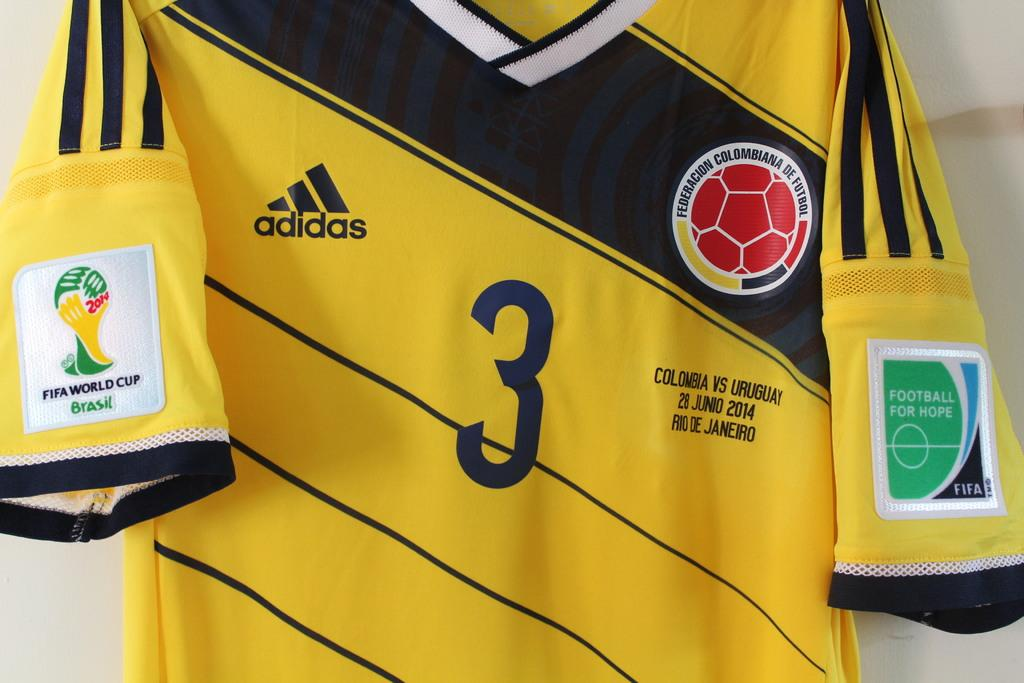<image>
Describe the image concisely. Yellow jersey with the number 3 on it. 